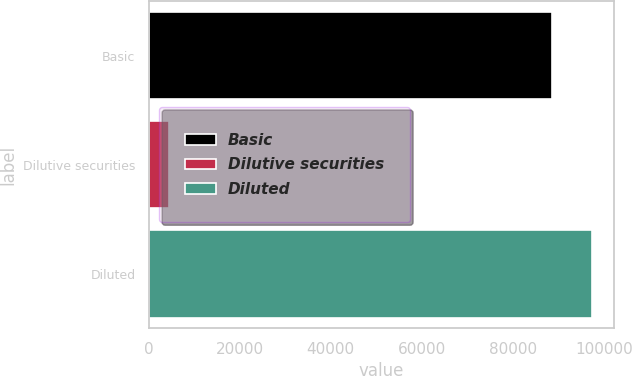<chart> <loc_0><loc_0><loc_500><loc_500><bar_chart><fcel>Basic<fcel>Dilutive securities<fcel>Diluted<nl><fcel>88514<fcel>4507<fcel>97365.4<nl></chart> 